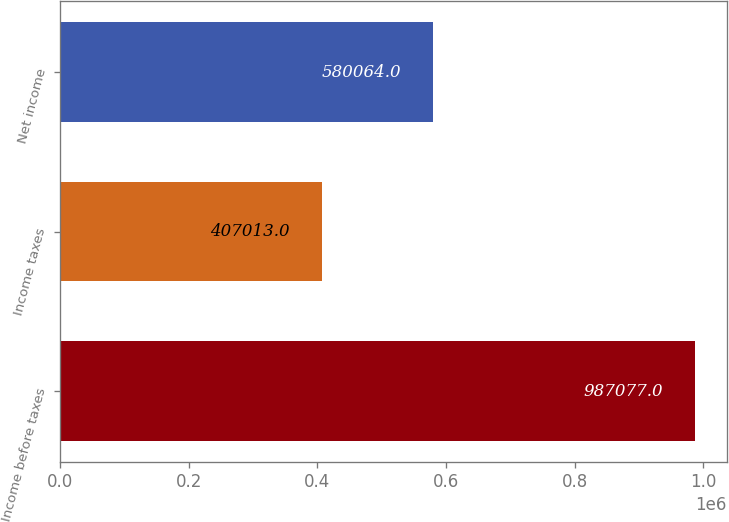Convert chart. <chart><loc_0><loc_0><loc_500><loc_500><bar_chart><fcel>Income before taxes<fcel>Income taxes<fcel>Net income<nl><fcel>987077<fcel>407013<fcel>580064<nl></chart> 